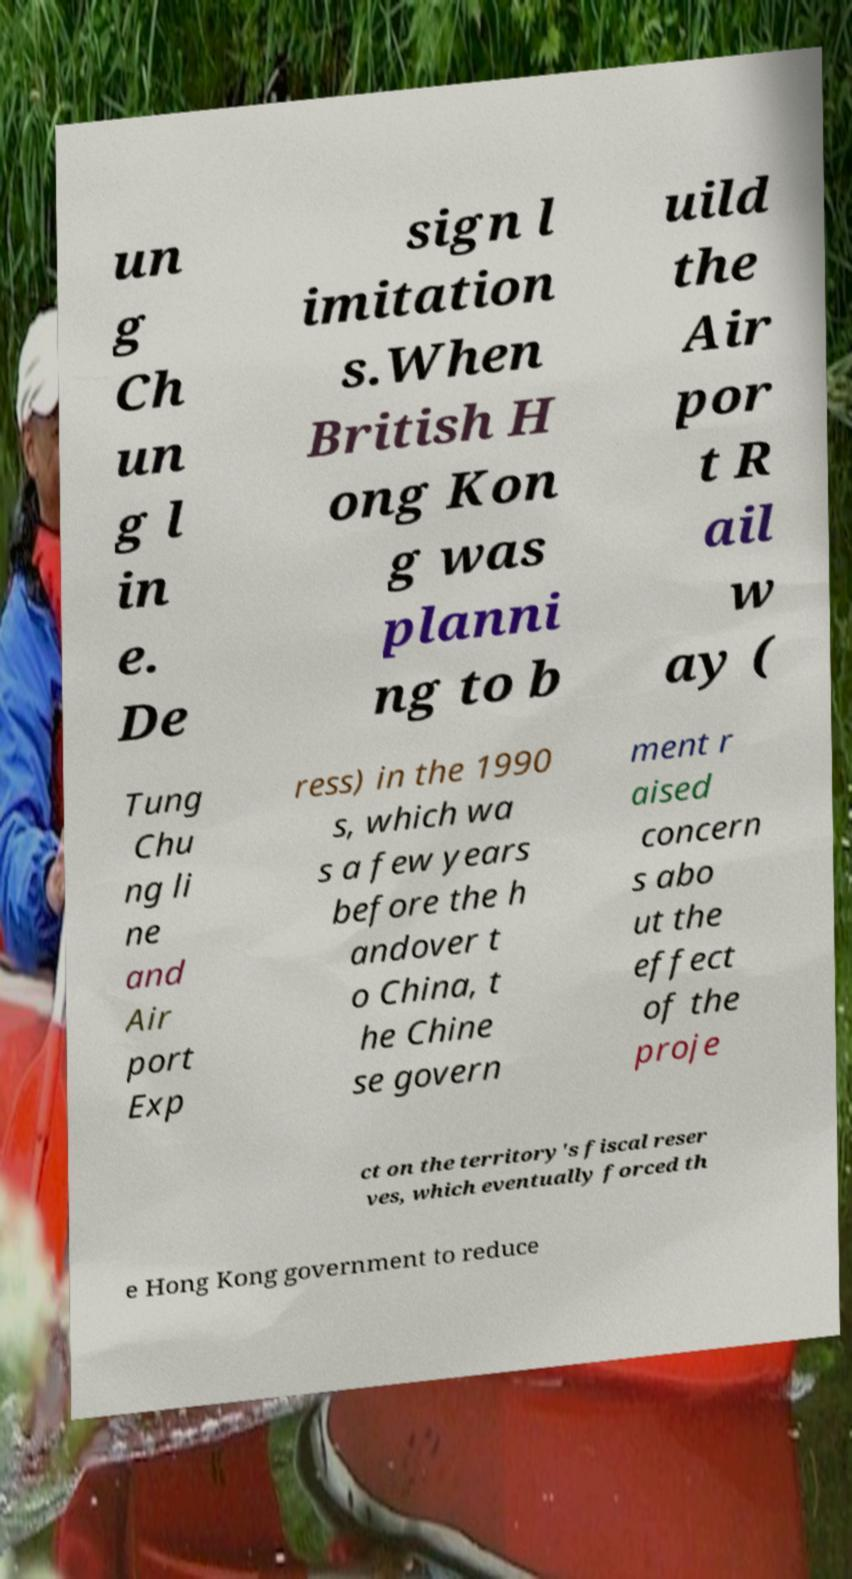What messages or text are displayed in this image? I need them in a readable, typed format. un g Ch un g l in e. De sign l imitation s.When British H ong Kon g was planni ng to b uild the Air por t R ail w ay ( Tung Chu ng li ne and Air port Exp ress) in the 1990 s, which wa s a few years before the h andover t o China, t he Chine se govern ment r aised concern s abo ut the effect of the proje ct on the territory's fiscal reser ves, which eventually forced th e Hong Kong government to reduce 